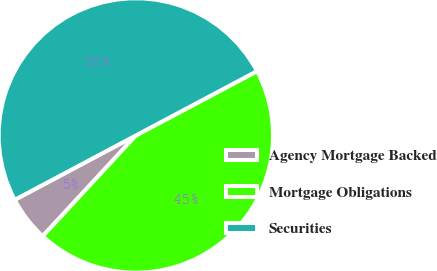Convert chart. <chart><loc_0><loc_0><loc_500><loc_500><pie_chart><fcel>Agency Mortgage Backed<fcel>Mortgage Obligations<fcel>Securities<nl><fcel>5.35%<fcel>44.65%<fcel>50.0%<nl></chart> 